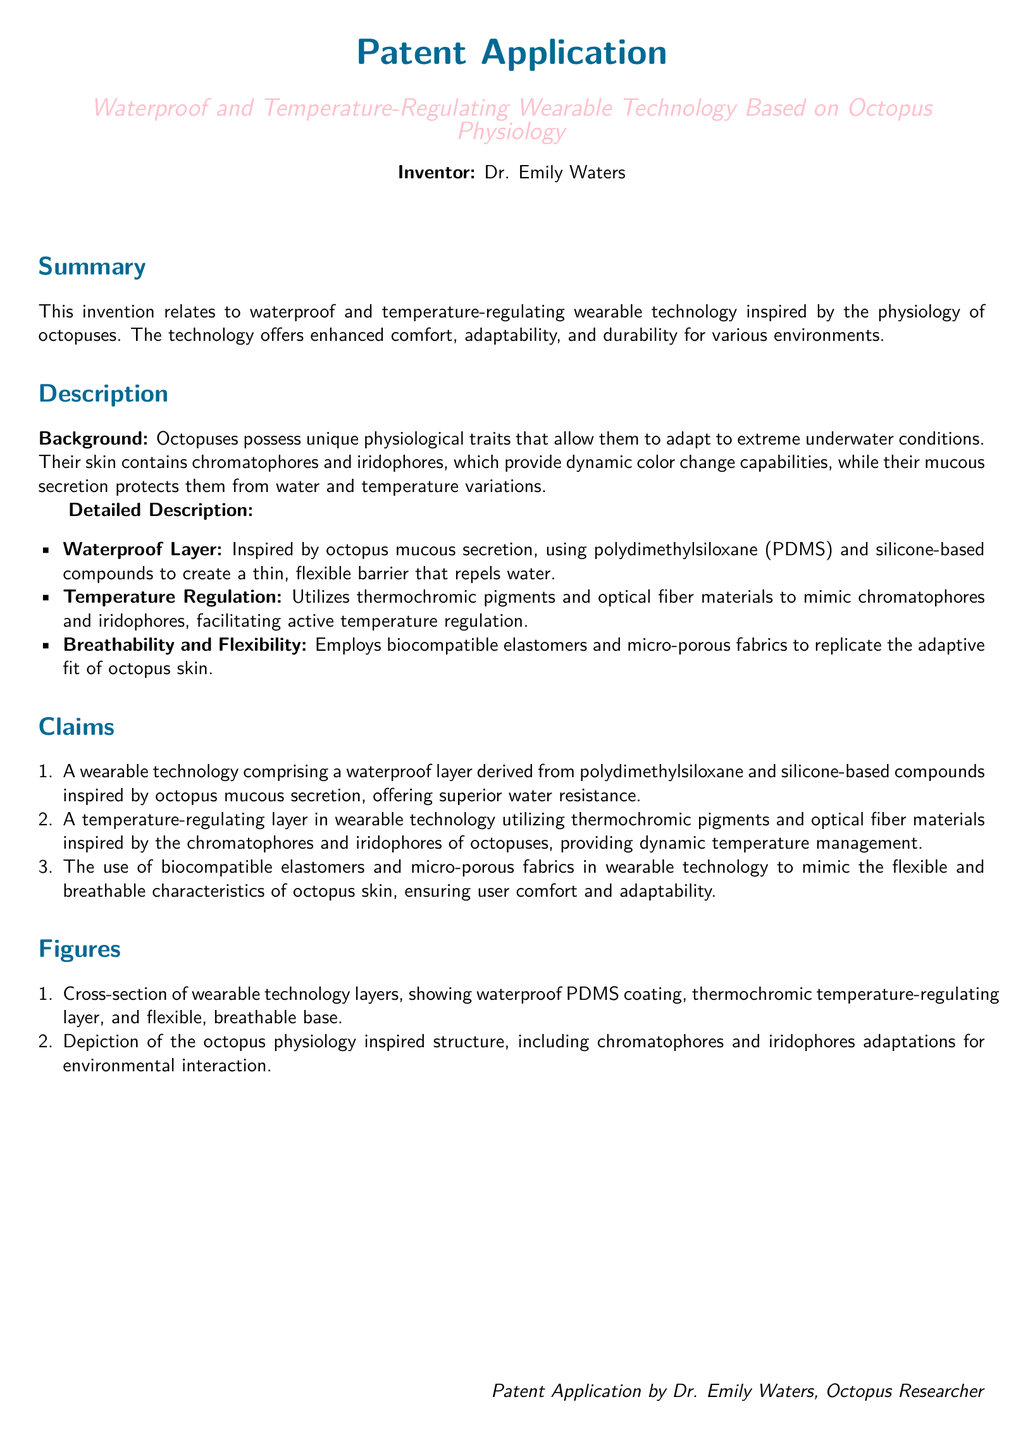What is the title of the patent application? The title of the patent application is stated at the beginning of the document.
Answer: Waterproof and Temperature-Regulating Wearable Technology Based on Octopus Physiology Who is the inventor of the technology? The inventor is mentioned in the document under the inventor section.
Answer: Dr. Emily Waters What material is used for the waterproof layer? The document specifies the materials used for the waterproof layer in the detailed description section.
Answer: Polydimethylsiloxane (PDMS) and silicone-based compounds What do chromatophores and iridophores provide? The document describes the unique physiological traits of octopuses and their functions.
Answer: Dynamic color change capabilities How many claims are made in the document? The total number of claims can be counted from the claims section of the document.
Answer: Three What type of fabrics are used for breathability? This information is detailed in the description section about the technology's materials.
Answer: Micro-porous fabrics Which section describes the background of the invention? The section headings indicate where background information can be found.
Answer: Background What is the purpose of thermochromic pigments in the technology? The use and purpose of thermochromic pigments are explained in the detailed description.
Answer: Dynamic temperature management 